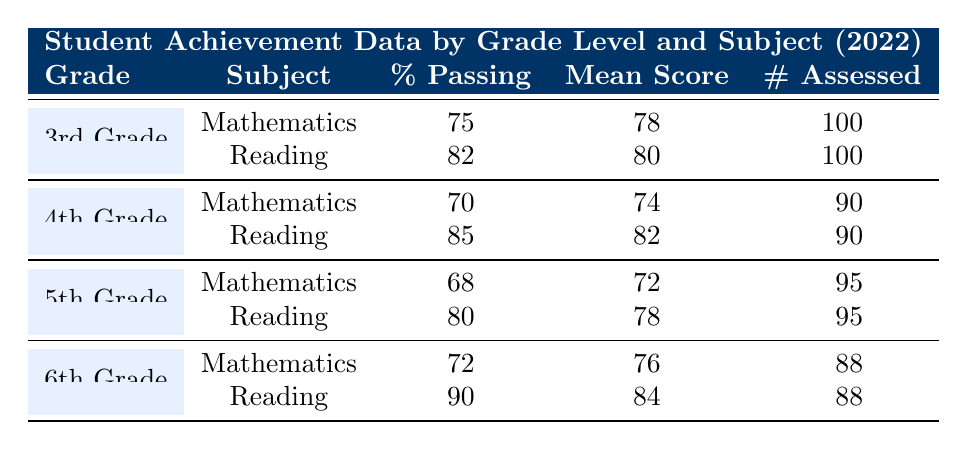What is the percentage of students passing in 5th Grade Reading? The table shows that for 5th Grade Reading, the percentage passing is listed as 80.
Answer: 80 What is the mean score for 6th Grade Mathematics? The table indicates that the mean score for 6th Grade Mathematics is 76.
Answer: 76 How many students were assessed in 4th Grade Reading? According to the table, the number of students assessed in 4th Grade Reading is 90.
Answer: 90 What is the average percentage passing for all grades in Mathematics? To find the average percentage passing for Mathematics, we sum the percentages: (75 + 70 + 68 + 72) = 285. Then we divide by the number of grades, which is 4, resulting in 285 / 4 = 71.25.
Answer: 71.25 Is the mean score for 3rd Grade Reading higher than that for 5th Grade Reading? The mean score for 3rd Grade Reading is 80, while the mean score for 5th Grade Reading is 78. Since 80 is greater than 78, the answer is yes.
Answer: Yes Which grade had the highest percentage of students passing in Reading? The table shows that 6th Grade has the highest percentage passing in Reading at 90%, compared to 82% for 3rd Grade, 85% for 4th Grade, and 80% for 5th Grade.
Answer: 6th Grade What is the difference in mean scores between 4th Grade Mathematics and 6th Grade Mathematics? The mean score for 4th Grade Mathematics is 74, and for 6th Grade Mathematics, it is 76. To find the difference, we subtract 74 from 76, which results in a difference of 2.
Answer: 2 For which grade and subject combination was the lowest percentage passing recorded? Looking at the percentages passing, 5th Grade Mathematics recorded the lowest percentage at 68%. Thus, the combination is 5th Grade Mathematics.
Answer: 5th Grade Mathematics How many total students were assessed across all grades for Mathematics? We add the number of students assessed in Mathematics across all grades: 100 (3rd) + 90 (4th) + 95 (5th) + 88 (6th) = 373.
Answer: 373 